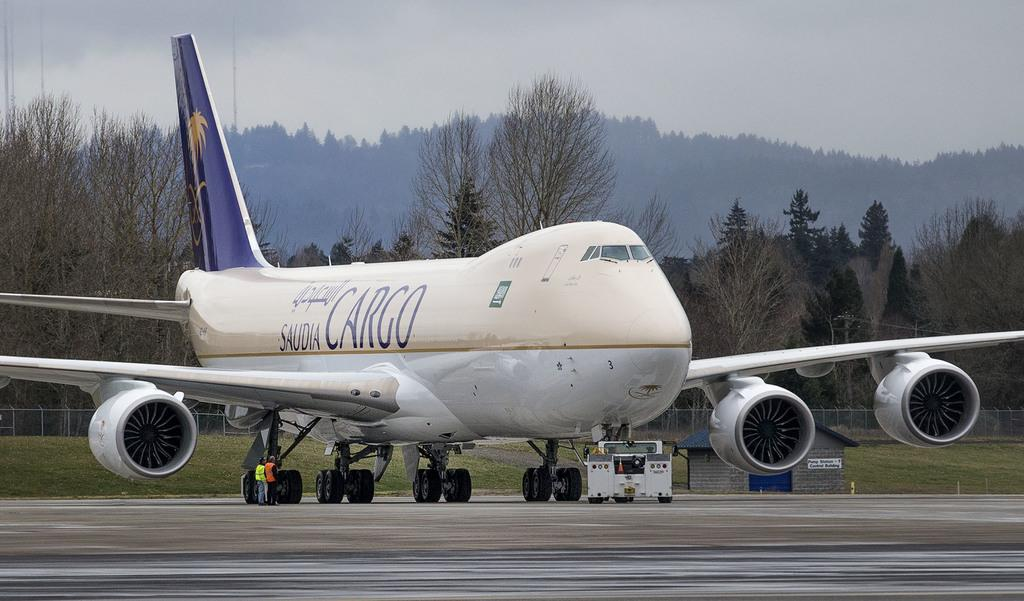Provide a one-sentence caption for the provided image. A plan on the runway reads "CARGO" on the side. 